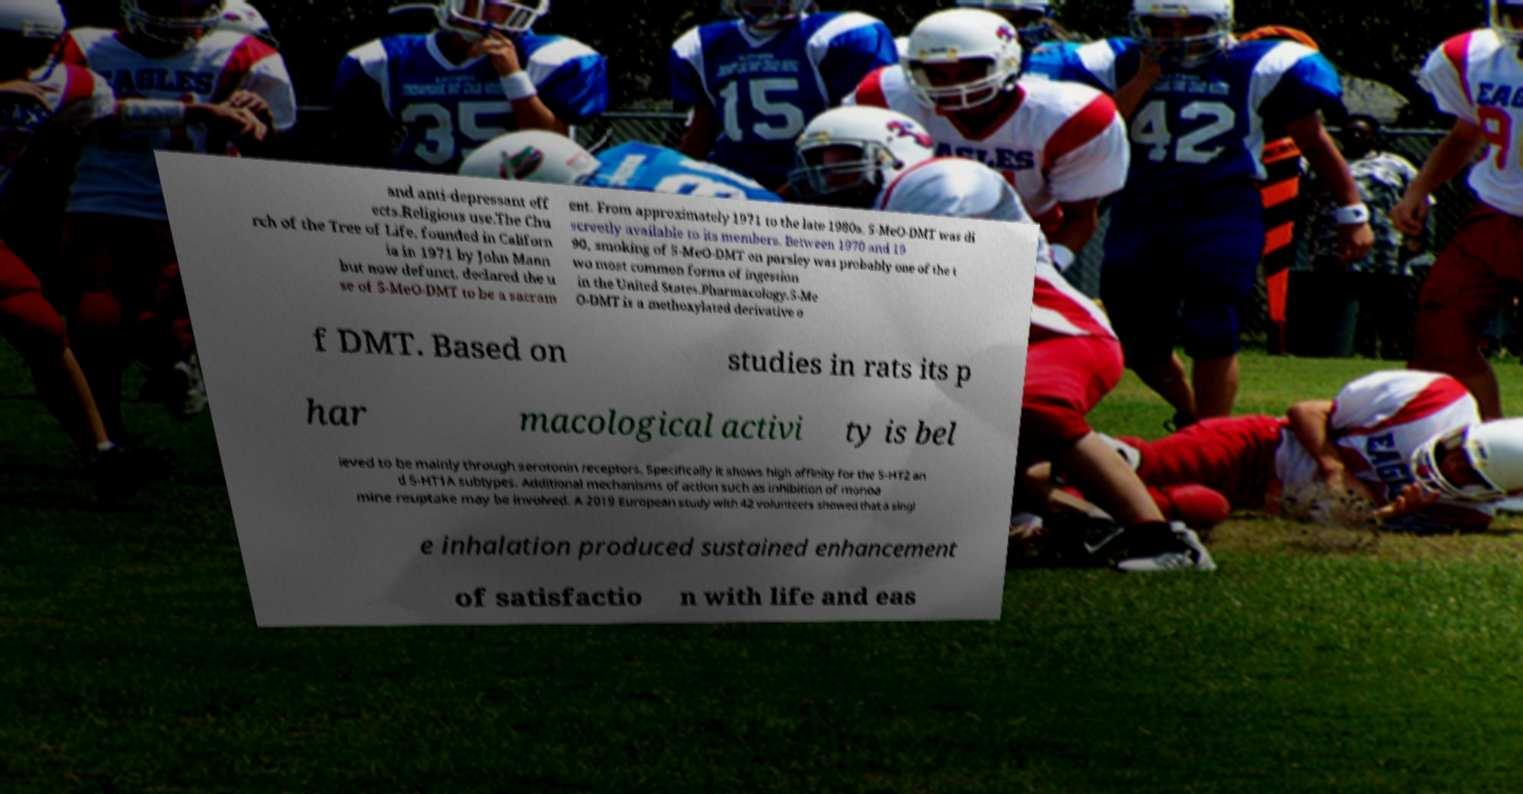Please identify and transcribe the text found in this image. and anti-depressant eff ects.Religious use.The Chu rch of the Tree of Life, founded in Californ ia in 1971 by John Mann but now defunct, declared the u se of 5-MeO-DMT to be a sacram ent. From approximately 1971 to the late 1980s, 5-MeO-DMT was di screetly available to its members. Between 1970 and 19 90, smoking of 5-MeO-DMT on parsley was probably one of the t wo most common forms of ingestion in the United States.Pharmacology.5-Me O-DMT is a methoxylated derivative o f DMT. Based on studies in rats its p har macological activi ty is bel ieved to be mainly through serotonin receptors. Specifically it shows high affinity for the 5-HT2 an d 5-HT1A subtypes. Additional mechanisms of action such as inhibition of monoa mine reuptake may be involved. A 2019 European study with 42 volunteers showed that a singl e inhalation produced sustained enhancement of satisfactio n with life and eas 